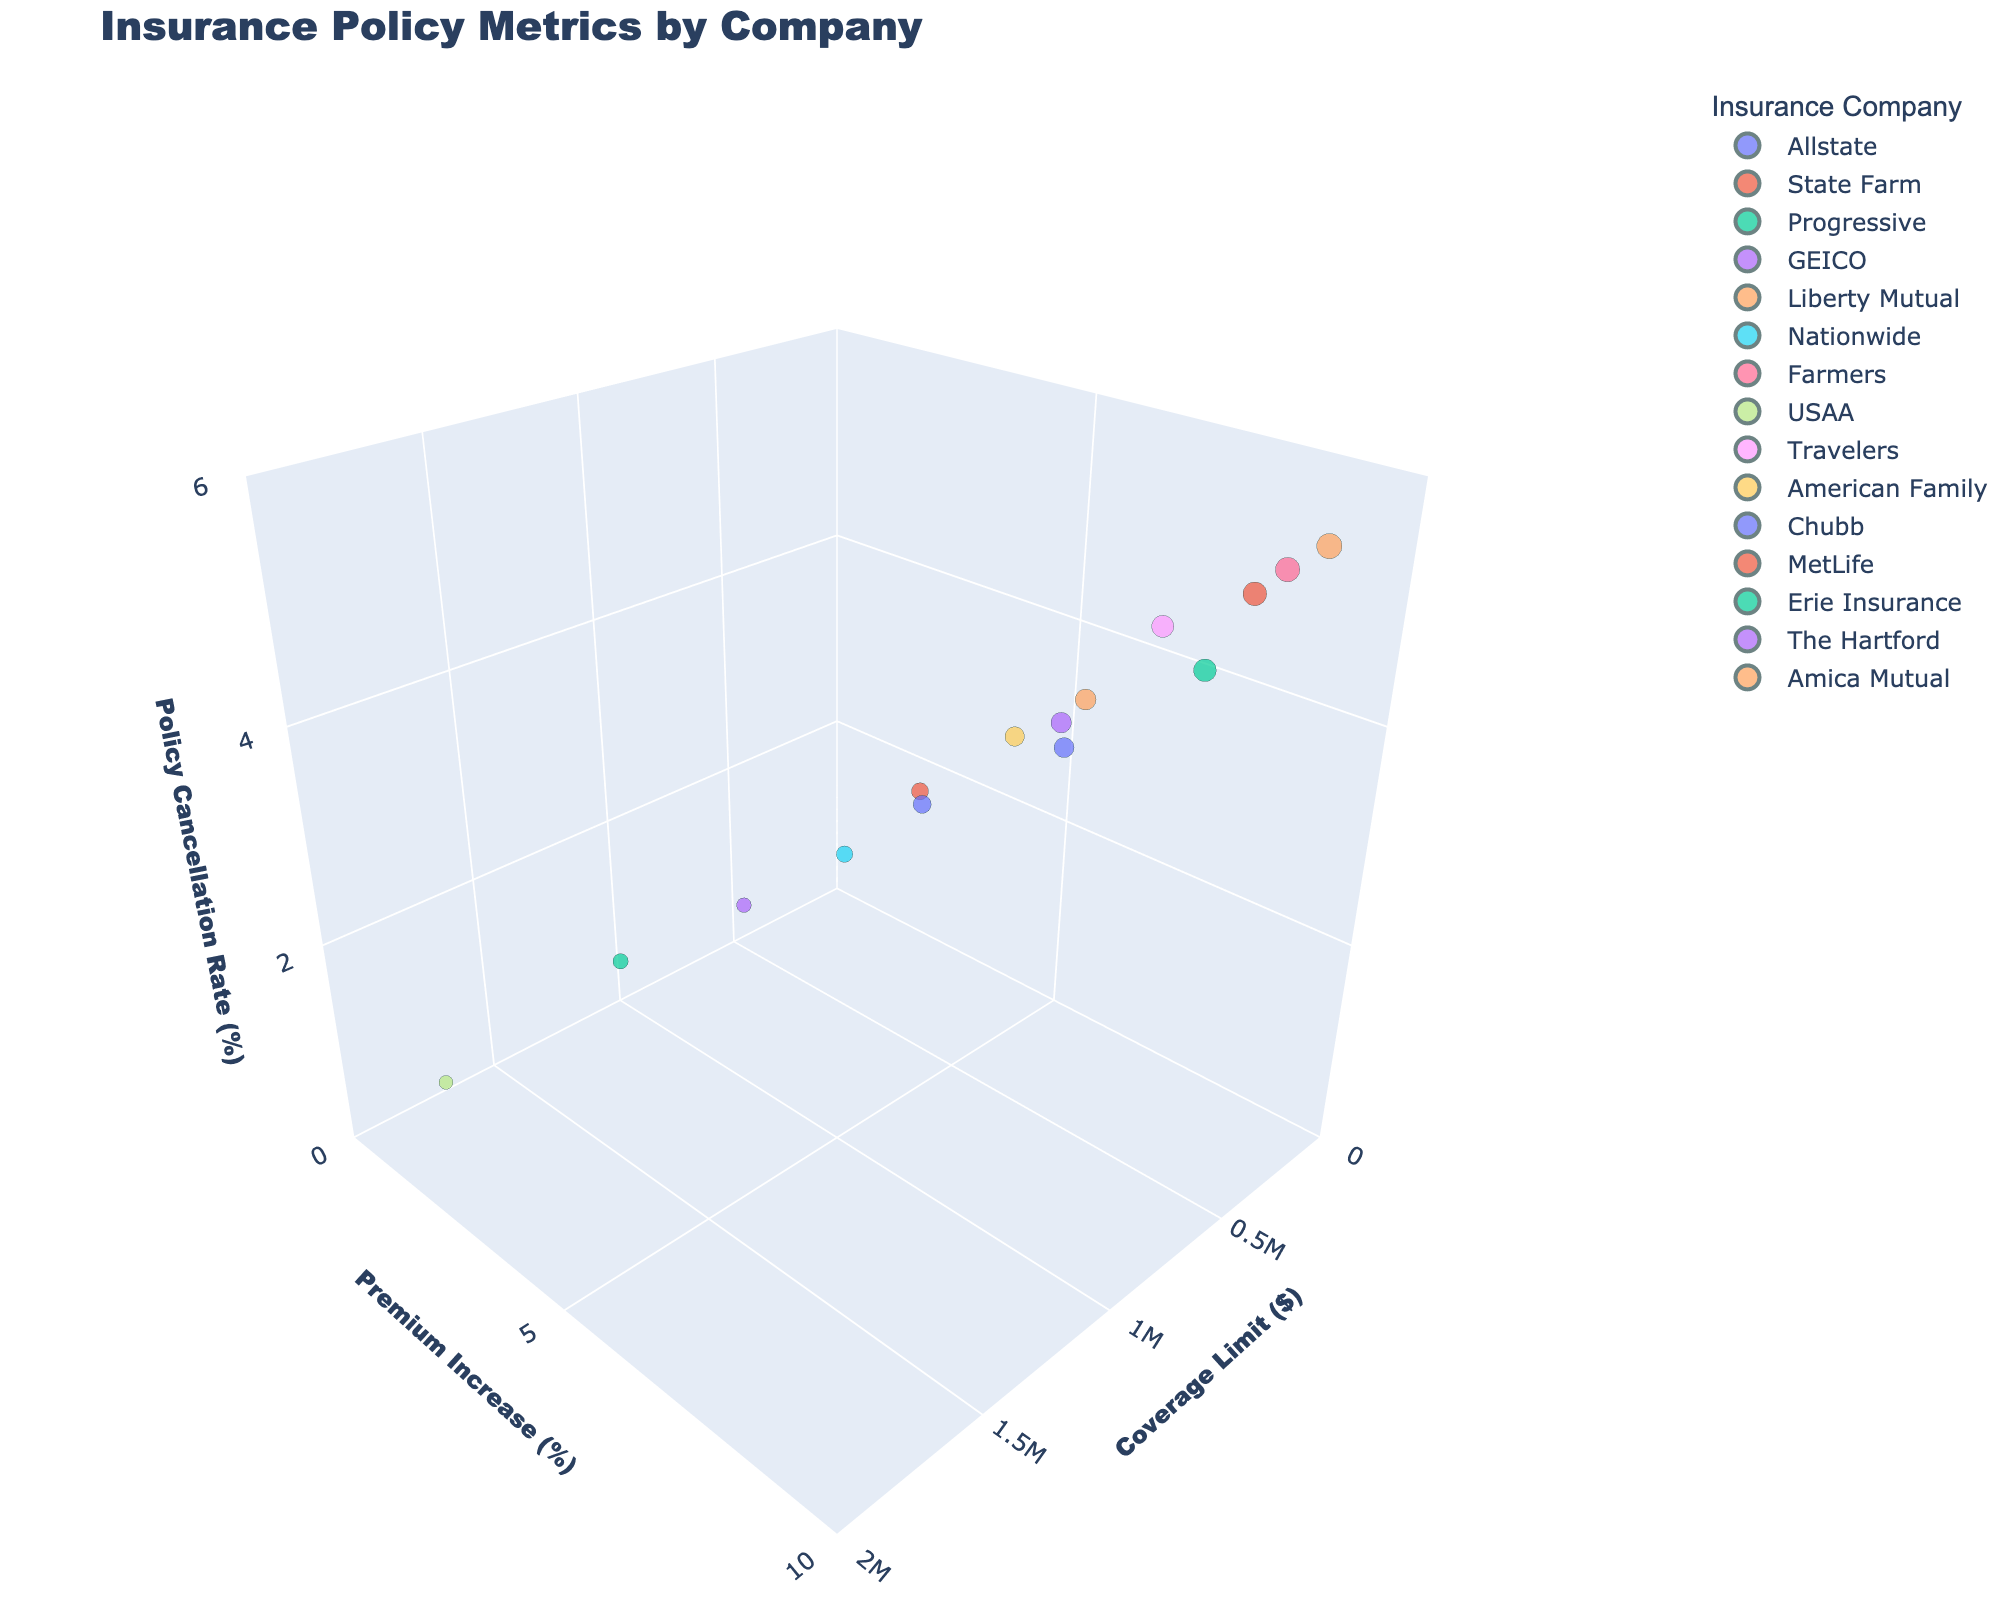What is the title of the 3D scatter plot? The title is prominently displayed at the top of the plot in bold and larger font size compared to other text, which indicates the main topic or dataset visualized.
Answer: Insurance Policy Metrics by Company Which company has the highest policy cancellation rate? Check the z-axis labeled 'Policy Cancellation Rate (%)' and find the data point that reaches the highest value along this axis. The hover label or color code will identify the corresponding insurance company.
Answer: Amica Mutual What are the three axes labeled as in the 3D scatter plot? The labels of the axes can be found at the end of each axis line. These labels describe what each axis represents.
Answer: Coverage Limit ($), Premium Increase (%), Policy Cancellation Rate (%) How many insurance companies are represented in the plot? Count the number of unique names or data points identified by different colors and/or hover labels for each insurance company.
Answer: 15 Which company has a coverage limit of 2,000,000$ and what is its premium increase? Locate the point on the x-axis corresponding to 2,000,000$ and check the y-axis and z-axis values of that point. The hover label will show the insurance company's name.
Answer: USAA, 2.8% Which company has the lowest premium increase, and what is its value? Find the data point that has the lowest position along the y-axis, labeled 'Premium Increase (%)'. The hover label or color code will indicate the insurance company and its value.
Answer: USAA, 2.8% What is the relationship between premium increases and policy cancellation rates? Observe the trend between the y-axis (Premium Increase) and the z-axis (Policy Cancellation Rate) values. Analyze whether higher premium increases tend to correlate with higher policy cancellation rates.
Answer: Generally, higher premium increases correspond to higher cancellation rates List the insurance companies with a premium increase greater than 7%. Find all data points where the y-axis value exceeds 7%. The hover labels or colors will identify the corresponding companies.
Answer: Farmers, MetLife, Amica Mutual, Travelers, Progressive Compare the policy cancellation rate of Farmers and USAA. Find the z-axis value for Farmers and USAA by locating their respective data points using color or hover labels. Compare these values.
Answer: Farmers: 5.2%, USAA: 1.5% Which insurance company offers the highest coverage limit and what's their policy cancellation rate? Identify the highest x-axis value on the plot. The corresponding hover label will show the company name, and the z-axis value reveals their policy cancellation rate.
Answer: USAA, 1.5% 